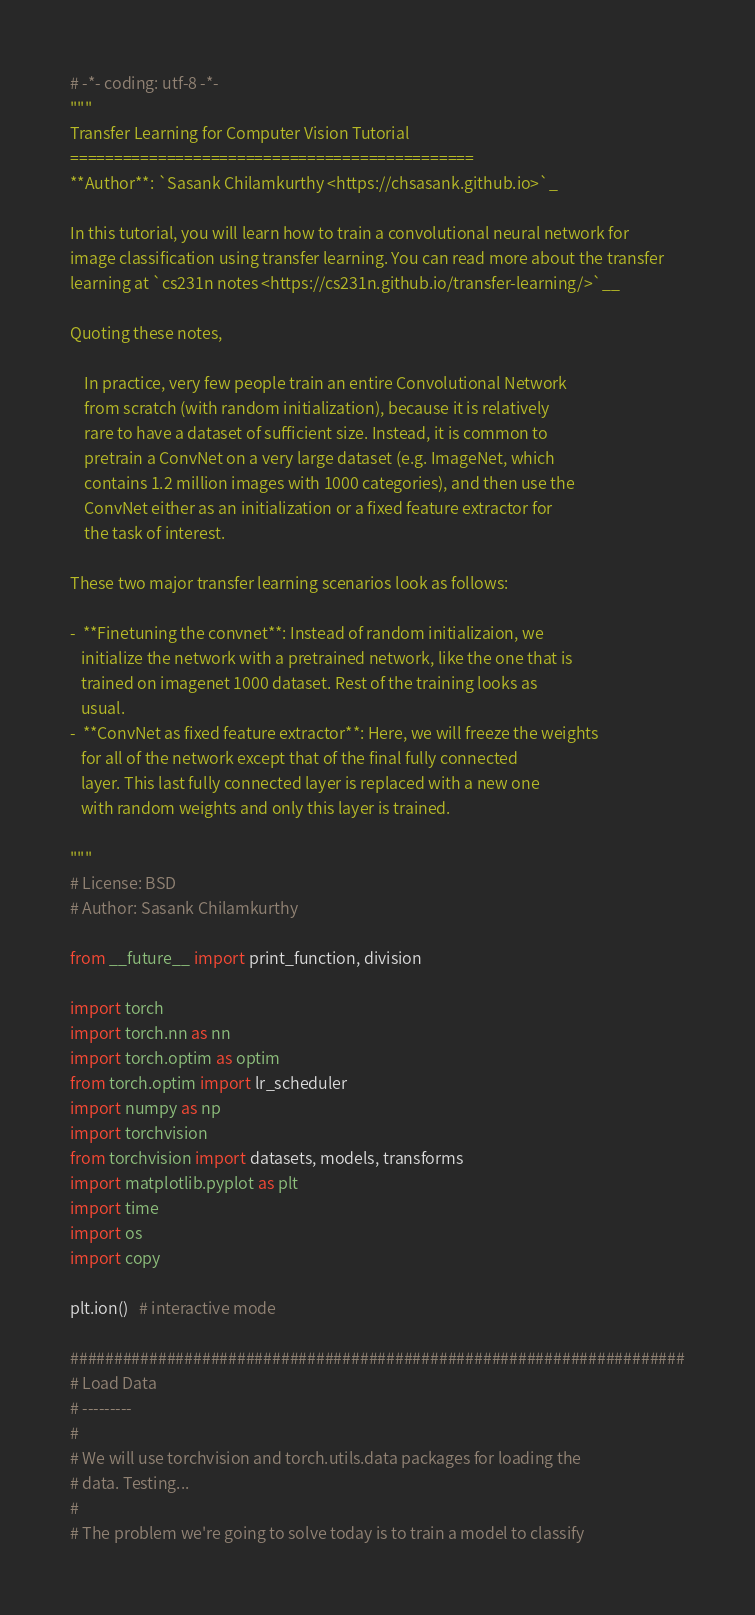<code> <loc_0><loc_0><loc_500><loc_500><_Python_># -*- coding: utf-8 -*-
"""
Transfer Learning for Computer Vision Tutorial
==============================================
**Author**: `Sasank Chilamkurthy <https://chsasank.github.io>`_

In this tutorial, you will learn how to train a convolutional neural network for
image classification using transfer learning. You can read more about the transfer
learning at `cs231n notes <https://cs231n.github.io/transfer-learning/>`__

Quoting these notes,

    In practice, very few people train an entire Convolutional Network
    from scratch (with random initialization), because it is relatively
    rare to have a dataset of sufficient size. Instead, it is common to
    pretrain a ConvNet on a very large dataset (e.g. ImageNet, which
    contains 1.2 million images with 1000 categories), and then use the
    ConvNet either as an initialization or a fixed feature extractor for
    the task of interest.

These two major transfer learning scenarios look as follows:

-  **Finetuning the convnet**: Instead of random initializaion, we
   initialize the network with a pretrained network, like the one that is
   trained on imagenet 1000 dataset. Rest of the training looks as
   usual.
-  **ConvNet as fixed feature extractor**: Here, we will freeze the weights
   for all of the network except that of the final fully connected
   layer. This last fully connected layer is replaced with a new one
   with random weights and only this layer is trained.

"""
# License: BSD
# Author: Sasank Chilamkurthy

from __future__ import print_function, division

import torch
import torch.nn as nn
import torch.optim as optim
from torch.optim import lr_scheduler
import numpy as np
import torchvision
from torchvision import datasets, models, transforms
import matplotlib.pyplot as plt
import time
import os
import copy

plt.ion()   # interactive mode

######################################################################
# Load Data
# ---------
#
# We will use torchvision and torch.utils.data packages for loading the
# data. Testing...
#
# The problem we're going to solve today is to train a model to classify</code> 